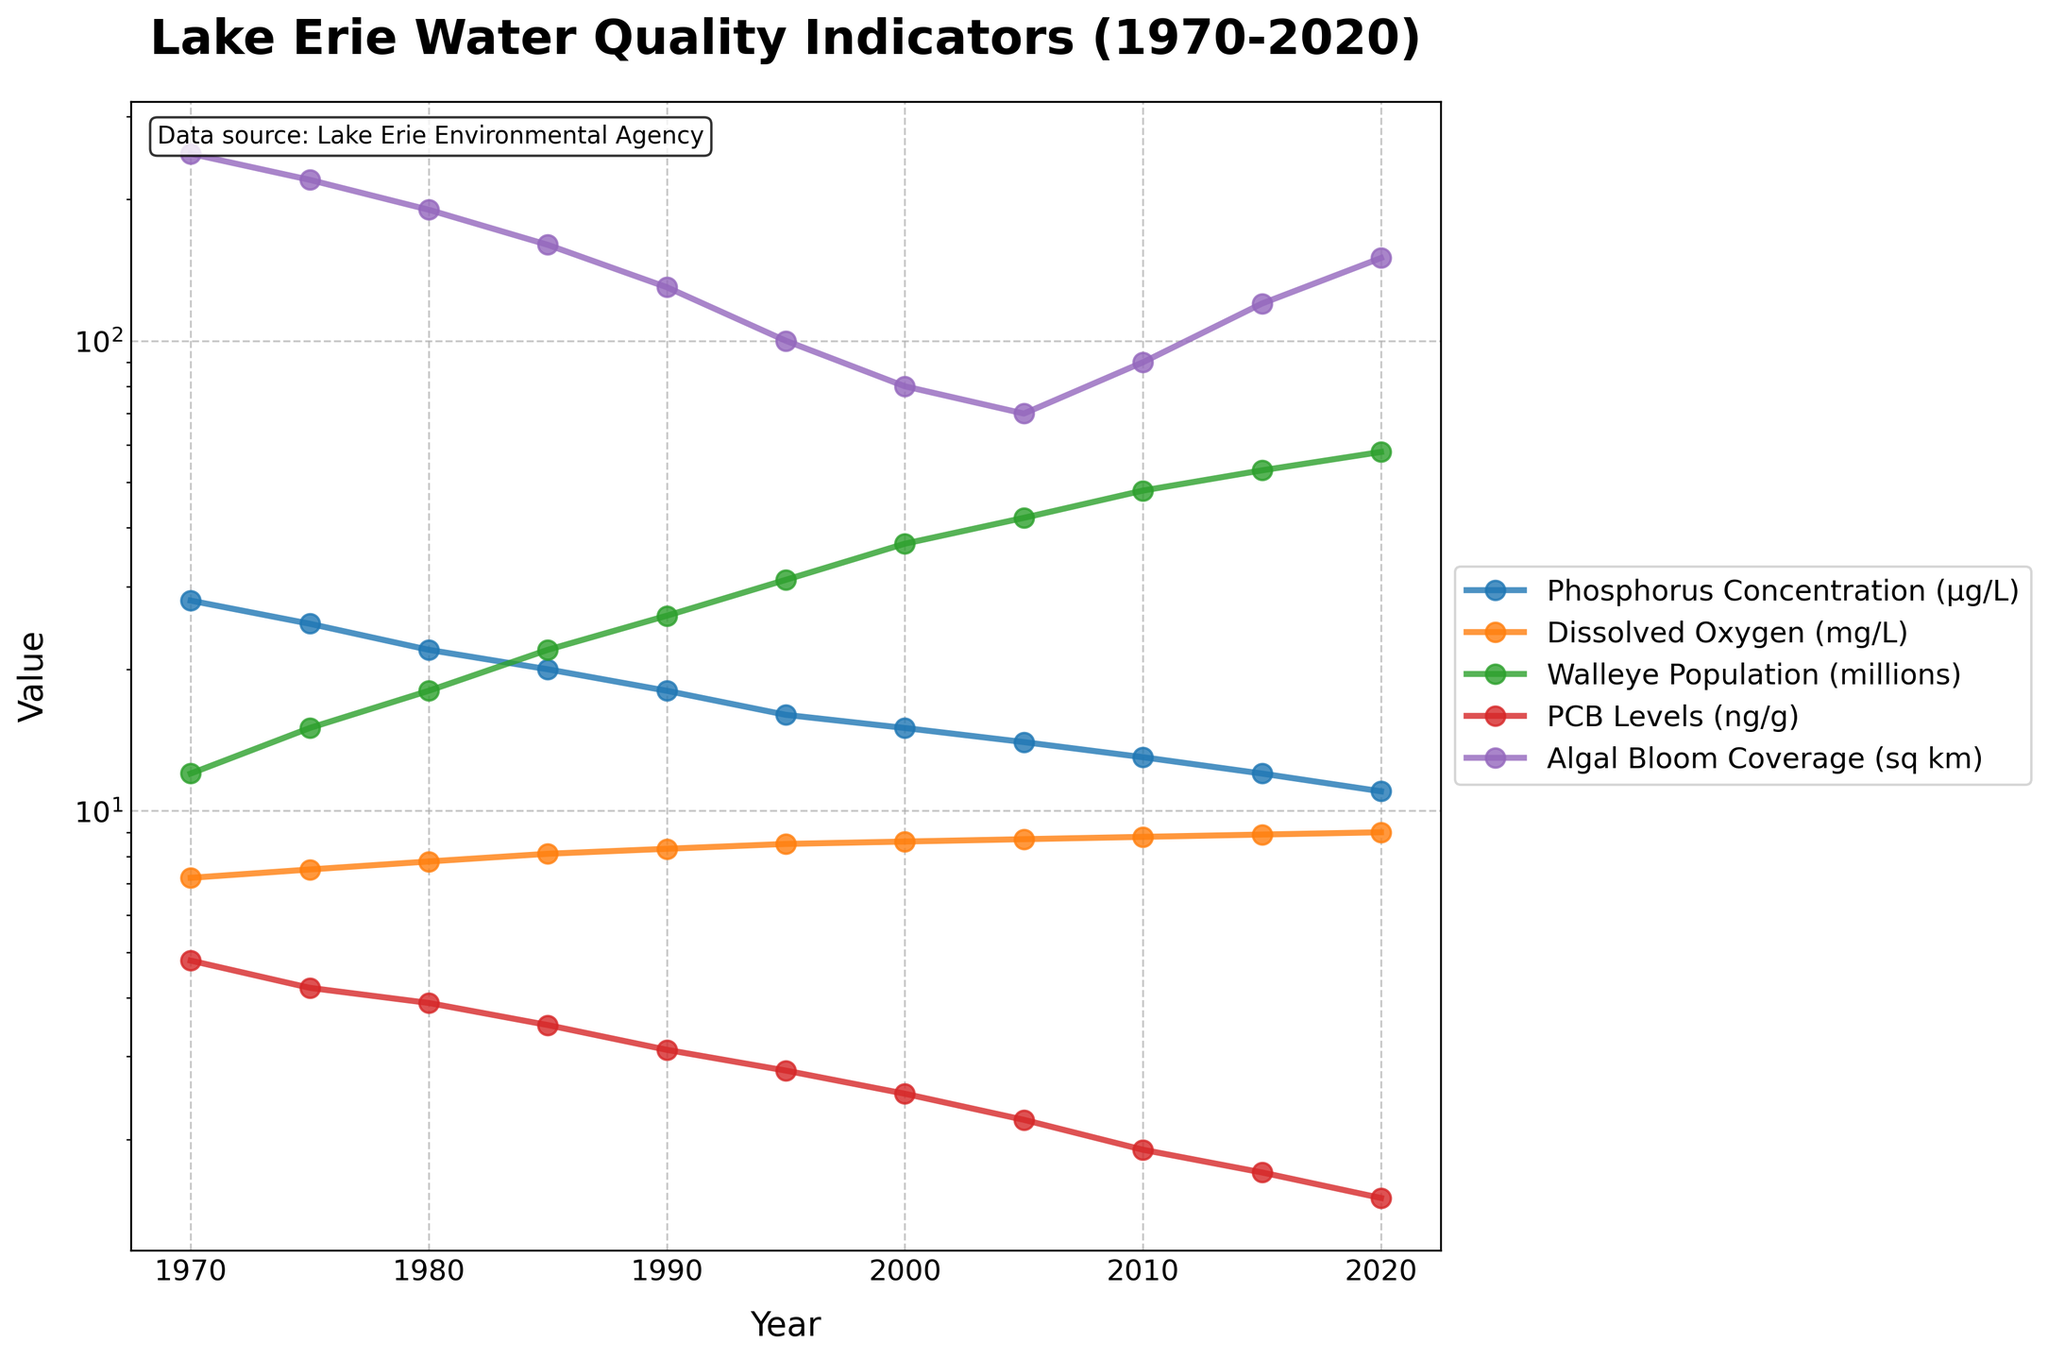What is the trend in phosphorus concentration over the years? By examining the line for phosphorus concentration, one can see that from 1970 to 2020, it shows a continuous decline. In 1970, it starts at 28 μg/L and decreases steadily to 11 μg/L in 2020.
Answer: continuous decline How does the walleye population in 1980 compare to 2000? By looking at the lines representing the walleye population, we can see that in 1980, the population was 18 million, whereas in 2000, it had increased to 37 million. This indicates a significant increase over the period.
Answer: increased What indicator shows the greatest improvement (increase) from 1970 to 2020? To find which indicator improved the most, we can look at the initial and final values for each indicator. The walleye population went from 12 million in 1970 to 58 million in 2020, which is the most significant increase among the indicators.
Answer: walleye population What year saw the highest dissolved oxygen level? By following the trend of the dissolved oxygen line, we notice that the highest value is reached in 2020 with a level of 9.0 mg/L.
Answer: 2020 Compare the trends of PCB levels and algal bloom coverage between 1975 and 2005. Observing the lines for PCB levels and algal bloom coverage, PCB levels show a continuous decline from 4.2 ng/g in 1975 to 2.2 ng/g in 2005. Algal bloom coverage also declines from 220 sq km in 1975 to 70 sq km in 2005, indicating both indicators show a decreasing trend.
Answer: both decreased What is the average phosphorus concentration from 1970 to 2020? The phosphorus concentrations over the years are: 28, 25, 22, 20, 18, 16, 15, 14, 13, 12, 11. Summing these values gives 194, and there are 11 data points. So, the average is 194/11 = 17.64 μg/L.
Answer: 17.64 μg/L How does the dissolved oxygen change correlate with the phosphorus concentration over the years? Examining the trends, as the phosphorus concentration decreases from 28 to 11 μg/L, the dissolved oxygen increases from 7.2 to 9.0 mg/L. This negative correlation suggests that as water becomes less nutrient-rich (lower phosphorus), oxygen levels improve.
Answer: negative correlation What's the median algal bloom coverage value over this time range? The algal bloom coverage values in ascending order are: 70, 80, 90, 100, 120, 130, 160, 190, 220, 250. With 11 data points, the median is the 6th value, which is 130 sq km.
Answer: 130 sq km Which year had the lowest PCB level, and what was the value? By examining the PCB levels over the years, 2020 has the lowest level, recorded at 1.5 ng/g.
Answer: 2020, 1.5 ng/g Considering all five indicators, which one had the most stable trend from 1970 to 2020? By comparing the lines for each indicator, the dissolved oxygen levels show the least fluctuation, smoothly increasing from 7.2 mg/L to 9.0 mg/L, indicating the most stability.
Answer: dissolved oxygen 